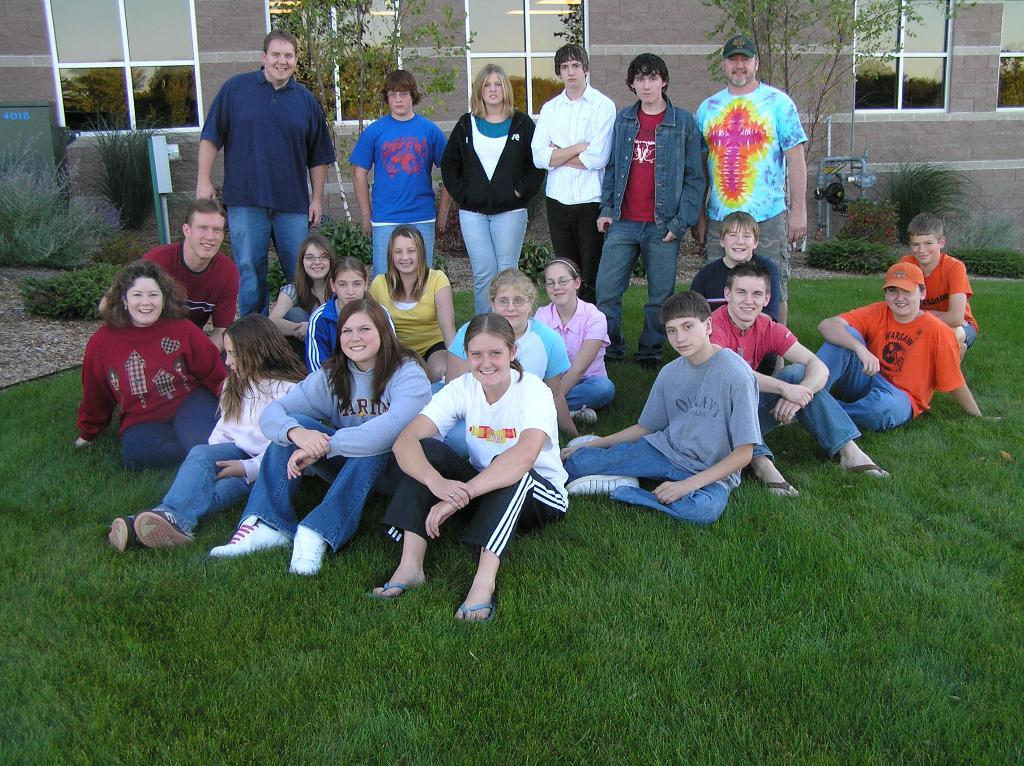What types of people are in the image? There are boys and girls in the image. Where are the boys and girls standing? They are standing on grassland. What can be seen behind the people in the image? There are people standing in front of a building, and trees are present in front of the building. What type of marble is being used to tell a story in the image? There is no marble or storytelling depicted in the image. 